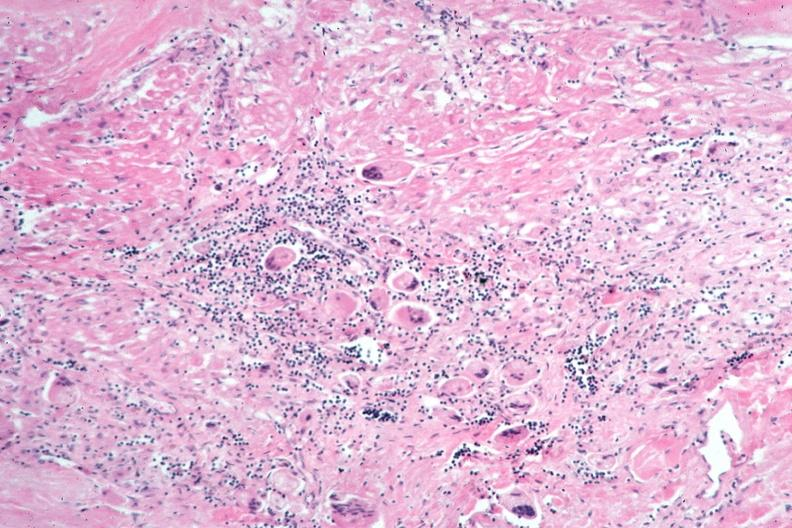what does this image show?
Answer the question using a single word or phrase. Lung 